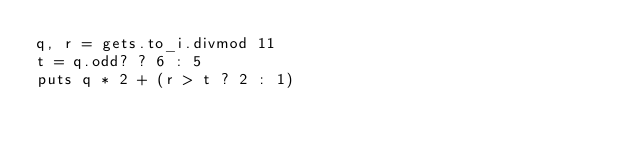Convert code to text. <code><loc_0><loc_0><loc_500><loc_500><_Ruby_>q, r = gets.to_i.divmod 11
t = q.odd? ? 6 : 5
puts q * 2 + (r > t ? 2 : 1)</code> 